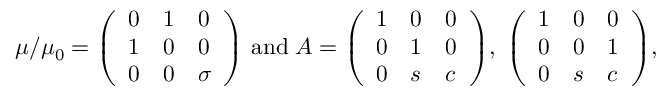<formula> <loc_0><loc_0><loc_500><loc_500>\mu / \mu _ { 0 } = \left ( \begin{array} { l l l } { 0 } & { 1 } & { 0 } \\ { 1 } & { 0 } & { 0 } \\ { 0 } & { 0 } & { \sigma } \end{array} \right ) \, a n d \, A = \left ( \begin{array} { l l l } { 1 } & { 0 } & { 0 } \\ { 0 } & { 1 } & { 0 } \\ { 0 } & { s } & { c } \end{array} \right ) \, , \, \left ( \begin{array} { l l l } { 1 } & { 0 } & { 0 } \\ { 0 } & { 0 } & { 1 } \\ { 0 } & { s } & { c } \end{array} \right ) \, ,</formula> 